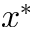Convert formula to latex. <formula><loc_0><loc_0><loc_500><loc_500>x ^ { * }</formula> 